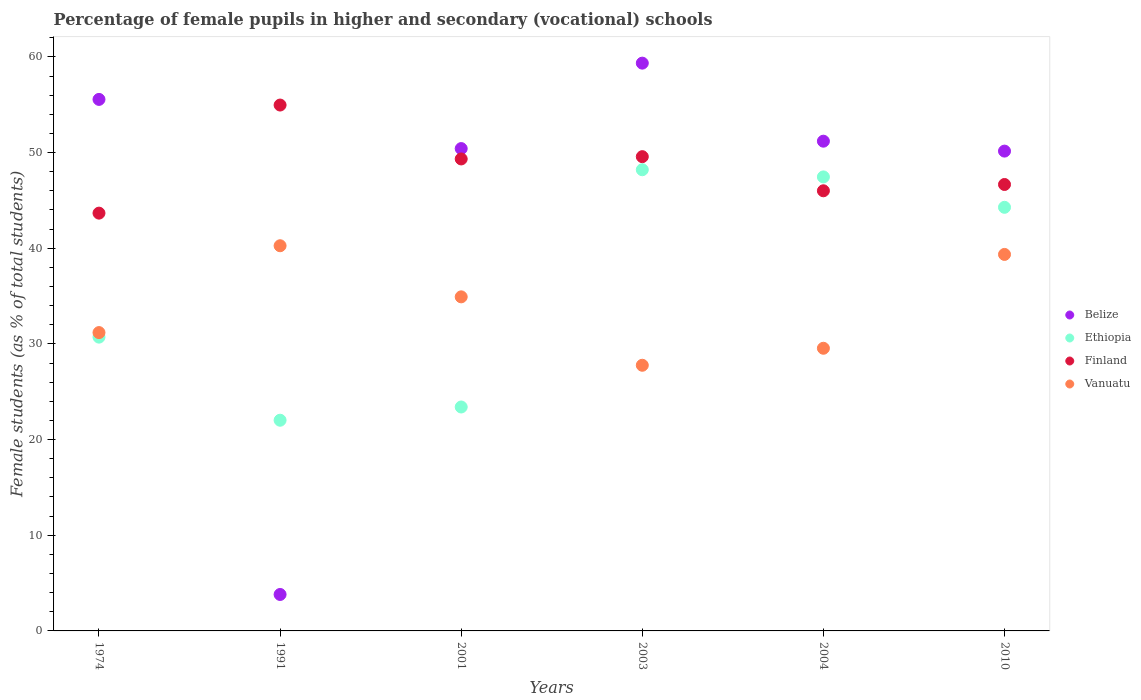How many different coloured dotlines are there?
Ensure brevity in your answer.  4. Is the number of dotlines equal to the number of legend labels?
Give a very brief answer. Yes. What is the percentage of female pupils in higher and secondary schools in Belize in 1991?
Offer a terse response. 3.81. Across all years, what is the maximum percentage of female pupils in higher and secondary schools in Belize?
Make the answer very short. 59.35. Across all years, what is the minimum percentage of female pupils in higher and secondary schools in Vanuatu?
Ensure brevity in your answer.  27.77. In which year was the percentage of female pupils in higher and secondary schools in Belize maximum?
Give a very brief answer. 2003. In which year was the percentage of female pupils in higher and secondary schools in Finland minimum?
Offer a terse response. 1974. What is the total percentage of female pupils in higher and secondary schools in Belize in the graph?
Give a very brief answer. 270.47. What is the difference between the percentage of female pupils in higher and secondary schools in Vanuatu in 1974 and that in 2004?
Your answer should be very brief. 1.64. What is the difference between the percentage of female pupils in higher and secondary schools in Vanuatu in 2004 and the percentage of female pupils in higher and secondary schools in Finland in 1991?
Your response must be concise. -25.42. What is the average percentage of female pupils in higher and secondary schools in Ethiopia per year?
Offer a very short reply. 36.01. In the year 2004, what is the difference between the percentage of female pupils in higher and secondary schools in Vanuatu and percentage of female pupils in higher and secondary schools in Ethiopia?
Your response must be concise. -17.91. What is the ratio of the percentage of female pupils in higher and secondary schools in Finland in 1974 to that in 2010?
Give a very brief answer. 0.94. What is the difference between the highest and the second highest percentage of female pupils in higher and secondary schools in Ethiopia?
Offer a very short reply. 0.75. What is the difference between the highest and the lowest percentage of female pupils in higher and secondary schools in Belize?
Your answer should be very brief. 55.54. Is it the case that in every year, the sum of the percentage of female pupils in higher and secondary schools in Ethiopia and percentage of female pupils in higher and secondary schools in Vanuatu  is greater than the sum of percentage of female pupils in higher and secondary schools in Belize and percentage of female pupils in higher and secondary schools in Finland?
Keep it short and to the point. No. Is it the case that in every year, the sum of the percentage of female pupils in higher and secondary schools in Finland and percentage of female pupils in higher and secondary schools in Vanuatu  is greater than the percentage of female pupils in higher and secondary schools in Belize?
Make the answer very short. Yes. Does the percentage of female pupils in higher and secondary schools in Ethiopia monotonically increase over the years?
Offer a very short reply. No. Is the percentage of female pupils in higher and secondary schools in Belize strictly greater than the percentage of female pupils in higher and secondary schools in Ethiopia over the years?
Your answer should be compact. No. Is the percentage of female pupils in higher and secondary schools in Belize strictly less than the percentage of female pupils in higher and secondary schools in Finland over the years?
Ensure brevity in your answer.  No. How many dotlines are there?
Your answer should be very brief. 4. How many years are there in the graph?
Offer a very short reply. 6. How are the legend labels stacked?
Keep it short and to the point. Vertical. What is the title of the graph?
Offer a terse response. Percentage of female pupils in higher and secondary (vocational) schools. Does "Hong Kong" appear as one of the legend labels in the graph?
Your response must be concise. No. What is the label or title of the X-axis?
Make the answer very short. Years. What is the label or title of the Y-axis?
Give a very brief answer. Female students (as % of total students). What is the Female students (as % of total students) in Belize in 1974?
Keep it short and to the point. 55.56. What is the Female students (as % of total students) in Ethiopia in 1974?
Provide a succinct answer. 30.71. What is the Female students (as % of total students) of Finland in 1974?
Your response must be concise. 43.67. What is the Female students (as % of total students) of Vanuatu in 1974?
Ensure brevity in your answer.  31.18. What is the Female students (as % of total students) in Belize in 1991?
Offer a very short reply. 3.81. What is the Female students (as % of total students) in Ethiopia in 1991?
Your answer should be very brief. 22.02. What is the Female students (as % of total students) in Finland in 1991?
Ensure brevity in your answer.  54.97. What is the Female students (as % of total students) of Vanuatu in 1991?
Your response must be concise. 40.26. What is the Female students (as % of total students) in Belize in 2001?
Make the answer very short. 50.41. What is the Female students (as % of total students) in Ethiopia in 2001?
Keep it short and to the point. 23.41. What is the Female students (as % of total students) of Finland in 2001?
Give a very brief answer. 49.33. What is the Female students (as % of total students) of Vanuatu in 2001?
Provide a short and direct response. 34.92. What is the Female students (as % of total students) of Belize in 2003?
Your answer should be very brief. 59.35. What is the Female students (as % of total students) in Ethiopia in 2003?
Ensure brevity in your answer.  48.2. What is the Female students (as % of total students) of Finland in 2003?
Give a very brief answer. 49.57. What is the Female students (as % of total students) in Vanuatu in 2003?
Ensure brevity in your answer.  27.77. What is the Female students (as % of total students) in Belize in 2004?
Your response must be concise. 51.19. What is the Female students (as % of total students) in Ethiopia in 2004?
Provide a succinct answer. 47.45. What is the Female students (as % of total students) in Finland in 2004?
Keep it short and to the point. 46. What is the Female students (as % of total students) of Vanuatu in 2004?
Offer a very short reply. 29.54. What is the Female students (as % of total students) of Belize in 2010?
Ensure brevity in your answer.  50.15. What is the Female students (as % of total students) of Ethiopia in 2010?
Ensure brevity in your answer.  44.28. What is the Female students (as % of total students) in Finland in 2010?
Offer a terse response. 46.66. What is the Female students (as % of total students) of Vanuatu in 2010?
Make the answer very short. 39.35. Across all years, what is the maximum Female students (as % of total students) in Belize?
Your response must be concise. 59.35. Across all years, what is the maximum Female students (as % of total students) of Ethiopia?
Keep it short and to the point. 48.2. Across all years, what is the maximum Female students (as % of total students) of Finland?
Offer a very short reply. 54.97. Across all years, what is the maximum Female students (as % of total students) in Vanuatu?
Your answer should be very brief. 40.26. Across all years, what is the minimum Female students (as % of total students) in Belize?
Give a very brief answer. 3.81. Across all years, what is the minimum Female students (as % of total students) of Ethiopia?
Offer a terse response. 22.02. Across all years, what is the minimum Female students (as % of total students) of Finland?
Your answer should be compact. 43.67. Across all years, what is the minimum Female students (as % of total students) of Vanuatu?
Your answer should be very brief. 27.77. What is the total Female students (as % of total students) of Belize in the graph?
Ensure brevity in your answer.  270.47. What is the total Female students (as % of total students) of Ethiopia in the graph?
Offer a very short reply. 216.07. What is the total Female students (as % of total students) in Finland in the graph?
Keep it short and to the point. 290.2. What is the total Female students (as % of total students) of Vanuatu in the graph?
Your answer should be very brief. 203.02. What is the difference between the Female students (as % of total students) in Belize in 1974 and that in 1991?
Your answer should be very brief. 51.75. What is the difference between the Female students (as % of total students) of Ethiopia in 1974 and that in 1991?
Offer a terse response. 8.69. What is the difference between the Female students (as % of total students) of Finland in 1974 and that in 1991?
Your response must be concise. -11.3. What is the difference between the Female students (as % of total students) of Vanuatu in 1974 and that in 1991?
Your response must be concise. -9.08. What is the difference between the Female students (as % of total students) of Belize in 1974 and that in 2001?
Keep it short and to the point. 5.14. What is the difference between the Female students (as % of total students) of Ethiopia in 1974 and that in 2001?
Offer a very short reply. 7.3. What is the difference between the Female students (as % of total students) of Finland in 1974 and that in 2001?
Make the answer very short. -5.66. What is the difference between the Female students (as % of total students) in Vanuatu in 1974 and that in 2001?
Offer a terse response. -3.73. What is the difference between the Female students (as % of total students) in Belize in 1974 and that in 2003?
Your answer should be very brief. -3.79. What is the difference between the Female students (as % of total students) of Ethiopia in 1974 and that in 2003?
Keep it short and to the point. -17.5. What is the difference between the Female students (as % of total students) in Finland in 1974 and that in 2003?
Make the answer very short. -5.9. What is the difference between the Female students (as % of total students) of Vanuatu in 1974 and that in 2003?
Your answer should be very brief. 3.42. What is the difference between the Female students (as % of total students) in Belize in 1974 and that in 2004?
Provide a short and direct response. 4.37. What is the difference between the Female students (as % of total students) in Ethiopia in 1974 and that in 2004?
Give a very brief answer. -16.75. What is the difference between the Female students (as % of total students) in Finland in 1974 and that in 2004?
Give a very brief answer. -2.34. What is the difference between the Female students (as % of total students) of Vanuatu in 1974 and that in 2004?
Make the answer very short. 1.64. What is the difference between the Female students (as % of total students) in Belize in 1974 and that in 2010?
Keep it short and to the point. 5.4. What is the difference between the Female students (as % of total students) of Ethiopia in 1974 and that in 2010?
Ensure brevity in your answer.  -13.57. What is the difference between the Female students (as % of total students) in Finland in 1974 and that in 2010?
Offer a very short reply. -2.99. What is the difference between the Female students (as % of total students) in Vanuatu in 1974 and that in 2010?
Provide a short and direct response. -8.17. What is the difference between the Female students (as % of total students) in Belize in 1991 and that in 2001?
Make the answer very short. -46.61. What is the difference between the Female students (as % of total students) of Ethiopia in 1991 and that in 2001?
Offer a very short reply. -1.38. What is the difference between the Female students (as % of total students) of Finland in 1991 and that in 2001?
Give a very brief answer. 5.63. What is the difference between the Female students (as % of total students) in Vanuatu in 1991 and that in 2001?
Give a very brief answer. 5.34. What is the difference between the Female students (as % of total students) in Belize in 1991 and that in 2003?
Your answer should be compact. -55.54. What is the difference between the Female students (as % of total students) in Ethiopia in 1991 and that in 2003?
Make the answer very short. -26.18. What is the difference between the Female students (as % of total students) of Finland in 1991 and that in 2003?
Your response must be concise. 5.39. What is the difference between the Female students (as % of total students) of Vanuatu in 1991 and that in 2003?
Give a very brief answer. 12.49. What is the difference between the Female students (as % of total students) in Belize in 1991 and that in 2004?
Ensure brevity in your answer.  -47.38. What is the difference between the Female students (as % of total students) in Ethiopia in 1991 and that in 2004?
Your response must be concise. -25.43. What is the difference between the Female students (as % of total students) of Finland in 1991 and that in 2004?
Your answer should be compact. 8.96. What is the difference between the Female students (as % of total students) of Vanuatu in 1991 and that in 2004?
Give a very brief answer. 10.72. What is the difference between the Female students (as % of total students) of Belize in 1991 and that in 2010?
Make the answer very short. -46.34. What is the difference between the Female students (as % of total students) in Ethiopia in 1991 and that in 2010?
Offer a terse response. -22.25. What is the difference between the Female students (as % of total students) in Finland in 1991 and that in 2010?
Ensure brevity in your answer.  8.3. What is the difference between the Female students (as % of total students) of Vanuatu in 1991 and that in 2010?
Your response must be concise. 0.91. What is the difference between the Female students (as % of total students) in Belize in 2001 and that in 2003?
Provide a short and direct response. -8.93. What is the difference between the Female students (as % of total students) in Ethiopia in 2001 and that in 2003?
Give a very brief answer. -24.8. What is the difference between the Female students (as % of total students) of Finland in 2001 and that in 2003?
Offer a very short reply. -0.24. What is the difference between the Female students (as % of total students) in Vanuatu in 2001 and that in 2003?
Give a very brief answer. 7.15. What is the difference between the Female students (as % of total students) in Belize in 2001 and that in 2004?
Your response must be concise. -0.77. What is the difference between the Female students (as % of total students) in Ethiopia in 2001 and that in 2004?
Your response must be concise. -24.05. What is the difference between the Female students (as % of total students) in Finland in 2001 and that in 2004?
Make the answer very short. 3.33. What is the difference between the Female students (as % of total students) in Vanuatu in 2001 and that in 2004?
Provide a succinct answer. 5.37. What is the difference between the Female students (as % of total students) in Belize in 2001 and that in 2010?
Give a very brief answer. 0.26. What is the difference between the Female students (as % of total students) in Ethiopia in 2001 and that in 2010?
Provide a short and direct response. -20.87. What is the difference between the Female students (as % of total students) of Finland in 2001 and that in 2010?
Provide a short and direct response. 2.67. What is the difference between the Female students (as % of total students) in Vanuatu in 2001 and that in 2010?
Give a very brief answer. -4.43. What is the difference between the Female students (as % of total students) in Belize in 2003 and that in 2004?
Your response must be concise. 8.16. What is the difference between the Female students (as % of total students) of Ethiopia in 2003 and that in 2004?
Provide a short and direct response. 0.75. What is the difference between the Female students (as % of total students) of Finland in 2003 and that in 2004?
Provide a succinct answer. 3.57. What is the difference between the Female students (as % of total students) in Vanuatu in 2003 and that in 2004?
Offer a terse response. -1.78. What is the difference between the Female students (as % of total students) in Belize in 2003 and that in 2010?
Provide a succinct answer. 9.19. What is the difference between the Female students (as % of total students) in Ethiopia in 2003 and that in 2010?
Make the answer very short. 3.93. What is the difference between the Female students (as % of total students) of Finland in 2003 and that in 2010?
Provide a short and direct response. 2.91. What is the difference between the Female students (as % of total students) in Vanuatu in 2003 and that in 2010?
Provide a succinct answer. -11.59. What is the difference between the Female students (as % of total students) of Belize in 2004 and that in 2010?
Give a very brief answer. 1.04. What is the difference between the Female students (as % of total students) in Ethiopia in 2004 and that in 2010?
Offer a very short reply. 3.18. What is the difference between the Female students (as % of total students) of Finland in 2004 and that in 2010?
Offer a very short reply. -0.66. What is the difference between the Female students (as % of total students) in Vanuatu in 2004 and that in 2010?
Your response must be concise. -9.81. What is the difference between the Female students (as % of total students) of Belize in 1974 and the Female students (as % of total students) of Ethiopia in 1991?
Your answer should be very brief. 33.53. What is the difference between the Female students (as % of total students) of Belize in 1974 and the Female students (as % of total students) of Finland in 1991?
Provide a short and direct response. 0.59. What is the difference between the Female students (as % of total students) in Belize in 1974 and the Female students (as % of total students) in Vanuatu in 1991?
Provide a succinct answer. 15.3. What is the difference between the Female students (as % of total students) in Ethiopia in 1974 and the Female students (as % of total students) in Finland in 1991?
Provide a succinct answer. -24.26. What is the difference between the Female students (as % of total students) in Ethiopia in 1974 and the Female students (as % of total students) in Vanuatu in 1991?
Ensure brevity in your answer.  -9.55. What is the difference between the Female students (as % of total students) of Finland in 1974 and the Female students (as % of total students) of Vanuatu in 1991?
Offer a terse response. 3.41. What is the difference between the Female students (as % of total students) in Belize in 1974 and the Female students (as % of total students) in Ethiopia in 2001?
Offer a very short reply. 32.15. What is the difference between the Female students (as % of total students) of Belize in 1974 and the Female students (as % of total students) of Finland in 2001?
Make the answer very short. 6.22. What is the difference between the Female students (as % of total students) of Belize in 1974 and the Female students (as % of total students) of Vanuatu in 2001?
Your answer should be very brief. 20.64. What is the difference between the Female students (as % of total students) of Ethiopia in 1974 and the Female students (as % of total students) of Finland in 2001?
Provide a short and direct response. -18.62. What is the difference between the Female students (as % of total students) in Ethiopia in 1974 and the Female students (as % of total students) in Vanuatu in 2001?
Your response must be concise. -4.21. What is the difference between the Female students (as % of total students) in Finland in 1974 and the Female students (as % of total students) in Vanuatu in 2001?
Your answer should be very brief. 8.75. What is the difference between the Female students (as % of total students) in Belize in 1974 and the Female students (as % of total students) in Ethiopia in 2003?
Keep it short and to the point. 7.35. What is the difference between the Female students (as % of total students) of Belize in 1974 and the Female students (as % of total students) of Finland in 2003?
Your answer should be compact. 5.98. What is the difference between the Female students (as % of total students) in Belize in 1974 and the Female students (as % of total students) in Vanuatu in 2003?
Give a very brief answer. 27.79. What is the difference between the Female students (as % of total students) of Ethiopia in 1974 and the Female students (as % of total students) of Finland in 2003?
Your answer should be very brief. -18.86. What is the difference between the Female students (as % of total students) in Ethiopia in 1974 and the Female students (as % of total students) in Vanuatu in 2003?
Your answer should be very brief. 2.94. What is the difference between the Female students (as % of total students) in Finland in 1974 and the Female students (as % of total students) in Vanuatu in 2003?
Make the answer very short. 15.9. What is the difference between the Female students (as % of total students) of Belize in 1974 and the Female students (as % of total students) of Ethiopia in 2004?
Provide a short and direct response. 8.1. What is the difference between the Female students (as % of total students) of Belize in 1974 and the Female students (as % of total students) of Finland in 2004?
Keep it short and to the point. 9.55. What is the difference between the Female students (as % of total students) in Belize in 1974 and the Female students (as % of total students) in Vanuatu in 2004?
Keep it short and to the point. 26.01. What is the difference between the Female students (as % of total students) in Ethiopia in 1974 and the Female students (as % of total students) in Finland in 2004?
Provide a succinct answer. -15.3. What is the difference between the Female students (as % of total students) in Ethiopia in 1974 and the Female students (as % of total students) in Vanuatu in 2004?
Your answer should be very brief. 1.16. What is the difference between the Female students (as % of total students) of Finland in 1974 and the Female students (as % of total students) of Vanuatu in 2004?
Your answer should be compact. 14.12. What is the difference between the Female students (as % of total students) of Belize in 1974 and the Female students (as % of total students) of Ethiopia in 2010?
Offer a terse response. 11.28. What is the difference between the Female students (as % of total students) of Belize in 1974 and the Female students (as % of total students) of Finland in 2010?
Ensure brevity in your answer.  8.89. What is the difference between the Female students (as % of total students) in Belize in 1974 and the Female students (as % of total students) in Vanuatu in 2010?
Offer a very short reply. 16.2. What is the difference between the Female students (as % of total students) of Ethiopia in 1974 and the Female students (as % of total students) of Finland in 2010?
Your answer should be very brief. -15.95. What is the difference between the Female students (as % of total students) in Ethiopia in 1974 and the Female students (as % of total students) in Vanuatu in 2010?
Provide a short and direct response. -8.64. What is the difference between the Female students (as % of total students) in Finland in 1974 and the Female students (as % of total students) in Vanuatu in 2010?
Give a very brief answer. 4.32. What is the difference between the Female students (as % of total students) of Belize in 1991 and the Female students (as % of total students) of Ethiopia in 2001?
Make the answer very short. -19.6. What is the difference between the Female students (as % of total students) in Belize in 1991 and the Female students (as % of total students) in Finland in 2001?
Give a very brief answer. -45.52. What is the difference between the Female students (as % of total students) of Belize in 1991 and the Female students (as % of total students) of Vanuatu in 2001?
Offer a terse response. -31.11. What is the difference between the Female students (as % of total students) in Ethiopia in 1991 and the Female students (as % of total students) in Finland in 2001?
Make the answer very short. -27.31. What is the difference between the Female students (as % of total students) in Ethiopia in 1991 and the Female students (as % of total students) in Vanuatu in 2001?
Your answer should be very brief. -12.9. What is the difference between the Female students (as % of total students) of Finland in 1991 and the Female students (as % of total students) of Vanuatu in 2001?
Provide a short and direct response. 20.05. What is the difference between the Female students (as % of total students) of Belize in 1991 and the Female students (as % of total students) of Ethiopia in 2003?
Ensure brevity in your answer.  -44.39. What is the difference between the Female students (as % of total students) of Belize in 1991 and the Female students (as % of total students) of Finland in 2003?
Make the answer very short. -45.76. What is the difference between the Female students (as % of total students) in Belize in 1991 and the Female students (as % of total students) in Vanuatu in 2003?
Your response must be concise. -23.96. What is the difference between the Female students (as % of total students) of Ethiopia in 1991 and the Female students (as % of total students) of Finland in 2003?
Keep it short and to the point. -27.55. What is the difference between the Female students (as % of total students) of Ethiopia in 1991 and the Female students (as % of total students) of Vanuatu in 2003?
Keep it short and to the point. -5.74. What is the difference between the Female students (as % of total students) in Finland in 1991 and the Female students (as % of total students) in Vanuatu in 2003?
Provide a succinct answer. 27.2. What is the difference between the Female students (as % of total students) of Belize in 1991 and the Female students (as % of total students) of Ethiopia in 2004?
Provide a short and direct response. -43.64. What is the difference between the Female students (as % of total students) of Belize in 1991 and the Female students (as % of total students) of Finland in 2004?
Provide a short and direct response. -42.19. What is the difference between the Female students (as % of total students) of Belize in 1991 and the Female students (as % of total students) of Vanuatu in 2004?
Provide a short and direct response. -25.73. What is the difference between the Female students (as % of total students) in Ethiopia in 1991 and the Female students (as % of total students) in Finland in 2004?
Your response must be concise. -23.98. What is the difference between the Female students (as % of total students) of Ethiopia in 1991 and the Female students (as % of total students) of Vanuatu in 2004?
Offer a very short reply. -7.52. What is the difference between the Female students (as % of total students) in Finland in 1991 and the Female students (as % of total students) in Vanuatu in 2004?
Offer a very short reply. 25.42. What is the difference between the Female students (as % of total students) of Belize in 1991 and the Female students (as % of total students) of Ethiopia in 2010?
Give a very brief answer. -40.47. What is the difference between the Female students (as % of total students) in Belize in 1991 and the Female students (as % of total students) in Finland in 2010?
Give a very brief answer. -42.85. What is the difference between the Female students (as % of total students) of Belize in 1991 and the Female students (as % of total students) of Vanuatu in 2010?
Make the answer very short. -35.54. What is the difference between the Female students (as % of total students) of Ethiopia in 1991 and the Female students (as % of total students) of Finland in 2010?
Your response must be concise. -24.64. What is the difference between the Female students (as % of total students) of Ethiopia in 1991 and the Female students (as % of total students) of Vanuatu in 2010?
Provide a succinct answer. -17.33. What is the difference between the Female students (as % of total students) in Finland in 1991 and the Female students (as % of total students) in Vanuatu in 2010?
Your answer should be compact. 15.61. What is the difference between the Female students (as % of total students) in Belize in 2001 and the Female students (as % of total students) in Ethiopia in 2003?
Ensure brevity in your answer.  2.21. What is the difference between the Female students (as % of total students) of Belize in 2001 and the Female students (as % of total students) of Finland in 2003?
Your response must be concise. 0.84. What is the difference between the Female students (as % of total students) of Belize in 2001 and the Female students (as % of total students) of Vanuatu in 2003?
Your response must be concise. 22.65. What is the difference between the Female students (as % of total students) in Ethiopia in 2001 and the Female students (as % of total students) in Finland in 2003?
Your answer should be very brief. -26.17. What is the difference between the Female students (as % of total students) of Ethiopia in 2001 and the Female students (as % of total students) of Vanuatu in 2003?
Make the answer very short. -4.36. What is the difference between the Female students (as % of total students) of Finland in 2001 and the Female students (as % of total students) of Vanuatu in 2003?
Your answer should be compact. 21.57. What is the difference between the Female students (as % of total students) of Belize in 2001 and the Female students (as % of total students) of Ethiopia in 2004?
Make the answer very short. 2.96. What is the difference between the Female students (as % of total students) in Belize in 2001 and the Female students (as % of total students) in Finland in 2004?
Offer a terse response. 4.41. What is the difference between the Female students (as % of total students) in Belize in 2001 and the Female students (as % of total students) in Vanuatu in 2004?
Offer a very short reply. 20.87. What is the difference between the Female students (as % of total students) in Ethiopia in 2001 and the Female students (as % of total students) in Finland in 2004?
Your answer should be very brief. -22.6. What is the difference between the Female students (as % of total students) in Ethiopia in 2001 and the Female students (as % of total students) in Vanuatu in 2004?
Ensure brevity in your answer.  -6.14. What is the difference between the Female students (as % of total students) of Finland in 2001 and the Female students (as % of total students) of Vanuatu in 2004?
Offer a terse response. 19.79. What is the difference between the Female students (as % of total students) of Belize in 2001 and the Female students (as % of total students) of Ethiopia in 2010?
Give a very brief answer. 6.14. What is the difference between the Female students (as % of total students) in Belize in 2001 and the Female students (as % of total students) in Finland in 2010?
Ensure brevity in your answer.  3.75. What is the difference between the Female students (as % of total students) in Belize in 2001 and the Female students (as % of total students) in Vanuatu in 2010?
Provide a succinct answer. 11.06. What is the difference between the Female students (as % of total students) of Ethiopia in 2001 and the Female students (as % of total students) of Finland in 2010?
Provide a short and direct response. -23.26. What is the difference between the Female students (as % of total students) of Ethiopia in 2001 and the Female students (as % of total students) of Vanuatu in 2010?
Your answer should be very brief. -15.95. What is the difference between the Female students (as % of total students) in Finland in 2001 and the Female students (as % of total students) in Vanuatu in 2010?
Make the answer very short. 9.98. What is the difference between the Female students (as % of total students) in Belize in 2003 and the Female students (as % of total students) in Ethiopia in 2004?
Your response must be concise. 11.89. What is the difference between the Female students (as % of total students) in Belize in 2003 and the Female students (as % of total students) in Finland in 2004?
Your answer should be compact. 13.34. What is the difference between the Female students (as % of total students) of Belize in 2003 and the Female students (as % of total students) of Vanuatu in 2004?
Provide a short and direct response. 29.8. What is the difference between the Female students (as % of total students) of Ethiopia in 2003 and the Female students (as % of total students) of Vanuatu in 2004?
Ensure brevity in your answer.  18.66. What is the difference between the Female students (as % of total students) in Finland in 2003 and the Female students (as % of total students) in Vanuatu in 2004?
Make the answer very short. 20.03. What is the difference between the Female students (as % of total students) of Belize in 2003 and the Female students (as % of total students) of Ethiopia in 2010?
Make the answer very short. 15.07. What is the difference between the Female students (as % of total students) in Belize in 2003 and the Female students (as % of total students) in Finland in 2010?
Your response must be concise. 12.68. What is the difference between the Female students (as % of total students) of Belize in 2003 and the Female students (as % of total students) of Vanuatu in 2010?
Your answer should be compact. 19.99. What is the difference between the Female students (as % of total students) in Ethiopia in 2003 and the Female students (as % of total students) in Finland in 2010?
Keep it short and to the point. 1.54. What is the difference between the Female students (as % of total students) of Ethiopia in 2003 and the Female students (as % of total students) of Vanuatu in 2010?
Provide a succinct answer. 8.85. What is the difference between the Female students (as % of total students) of Finland in 2003 and the Female students (as % of total students) of Vanuatu in 2010?
Keep it short and to the point. 10.22. What is the difference between the Female students (as % of total students) in Belize in 2004 and the Female students (as % of total students) in Ethiopia in 2010?
Keep it short and to the point. 6.91. What is the difference between the Female students (as % of total students) in Belize in 2004 and the Female students (as % of total students) in Finland in 2010?
Provide a short and direct response. 4.53. What is the difference between the Female students (as % of total students) of Belize in 2004 and the Female students (as % of total students) of Vanuatu in 2010?
Offer a very short reply. 11.84. What is the difference between the Female students (as % of total students) of Ethiopia in 2004 and the Female students (as % of total students) of Finland in 2010?
Offer a terse response. 0.79. What is the difference between the Female students (as % of total students) in Ethiopia in 2004 and the Female students (as % of total students) in Vanuatu in 2010?
Give a very brief answer. 8.1. What is the difference between the Female students (as % of total students) of Finland in 2004 and the Female students (as % of total students) of Vanuatu in 2010?
Give a very brief answer. 6.65. What is the average Female students (as % of total students) of Belize per year?
Offer a terse response. 45.08. What is the average Female students (as % of total students) in Ethiopia per year?
Offer a very short reply. 36.01. What is the average Female students (as % of total students) in Finland per year?
Your response must be concise. 48.37. What is the average Female students (as % of total students) in Vanuatu per year?
Your response must be concise. 33.84. In the year 1974, what is the difference between the Female students (as % of total students) in Belize and Female students (as % of total students) in Ethiopia?
Provide a succinct answer. 24.85. In the year 1974, what is the difference between the Female students (as % of total students) in Belize and Female students (as % of total students) in Finland?
Keep it short and to the point. 11.89. In the year 1974, what is the difference between the Female students (as % of total students) in Belize and Female students (as % of total students) in Vanuatu?
Offer a terse response. 24.37. In the year 1974, what is the difference between the Female students (as % of total students) of Ethiopia and Female students (as % of total students) of Finland?
Provide a succinct answer. -12.96. In the year 1974, what is the difference between the Female students (as % of total students) of Ethiopia and Female students (as % of total students) of Vanuatu?
Offer a terse response. -0.47. In the year 1974, what is the difference between the Female students (as % of total students) in Finland and Female students (as % of total students) in Vanuatu?
Provide a short and direct response. 12.48. In the year 1991, what is the difference between the Female students (as % of total students) of Belize and Female students (as % of total students) of Ethiopia?
Provide a succinct answer. -18.21. In the year 1991, what is the difference between the Female students (as % of total students) of Belize and Female students (as % of total students) of Finland?
Make the answer very short. -51.16. In the year 1991, what is the difference between the Female students (as % of total students) in Belize and Female students (as % of total students) in Vanuatu?
Offer a terse response. -36.45. In the year 1991, what is the difference between the Female students (as % of total students) of Ethiopia and Female students (as % of total students) of Finland?
Your response must be concise. -32.94. In the year 1991, what is the difference between the Female students (as % of total students) in Ethiopia and Female students (as % of total students) in Vanuatu?
Your response must be concise. -18.24. In the year 1991, what is the difference between the Female students (as % of total students) of Finland and Female students (as % of total students) of Vanuatu?
Provide a succinct answer. 14.71. In the year 2001, what is the difference between the Female students (as % of total students) of Belize and Female students (as % of total students) of Ethiopia?
Your response must be concise. 27.01. In the year 2001, what is the difference between the Female students (as % of total students) in Belize and Female students (as % of total students) in Finland?
Offer a very short reply. 1.08. In the year 2001, what is the difference between the Female students (as % of total students) in Belize and Female students (as % of total students) in Vanuatu?
Your answer should be compact. 15.5. In the year 2001, what is the difference between the Female students (as % of total students) in Ethiopia and Female students (as % of total students) in Finland?
Offer a terse response. -25.93. In the year 2001, what is the difference between the Female students (as % of total students) of Ethiopia and Female students (as % of total students) of Vanuatu?
Your response must be concise. -11.51. In the year 2001, what is the difference between the Female students (as % of total students) of Finland and Female students (as % of total students) of Vanuatu?
Ensure brevity in your answer.  14.41. In the year 2003, what is the difference between the Female students (as % of total students) in Belize and Female students (as % of total students) in Ethiopia?
Keep it short and to the point. 11.14. In the year 2003, what is the difference between the Female students (as % of total students) of Belize and Female students (as % of total students) of Finland?
Offer a very short reply. 9.78. In the year 2003, what is the difference between the Female students (as % of total students) of Belize and Female students (as % of total students) of Vanuatu?
Ensure brevity in your answer.  31.58. In the year 2003, what is the difference between the Female students (as % of total students) of Ethiopia and Female students (as % of total students) of Finland?
Offer a very short reply. -1.37. In the year 2003, what is the difference between the Female students (as % of total students) of Ethiopia and Female students (as % of total students) of Vanuatu?
Your answer should be compact. 20.44. In the year 2003, what is the difference between the Female students (as % of total students) in Finland and Female students (as % of total students) in Vanuatu?
Your answer should be very brief. 21.8. In the year 2004, what is the difference between the Female students (as % of total students) of Belize and Female students (as % of total students) of Ethiopia?
Keep it short and to the point. 3.73. In the year 2004, what is the difference between the Female students (as % of total students) of Belize and Female students (as % of total students) of Finland?
Provide a succinct answer. 5.18. In the year 2004, what is the difference between the Female students (as % of total students) of Belize and Female students (as % of total students) of Vanuatu?
Provide a short and direct response. 21.64. In the year 2004, what is the difference between the Female students (as % of total students) of Ethiopia and Female students (as % of total students) of Finland?
Ensure brevity in your answer.  1.45. In the year 2004, what is the difference between the Female students (as % of total students) in Ethiopia and Female students (as % of total students) in Vanuatu?
Ensure brevity in your answer.  17.91. In the year 2004, what is the difference between the Female students (as % of total students) in Finland and Female students (as % of total students) in Vanuatu?
Offer a very short reply. 16.46. In the year 2010, what is the difference between the Female students (as % of total students) of Belize and Female students (as % of total students) of Ethiopia?
Your answer should be very brief. 5.87. In the year 2010, what is the difference between the Female students (as % of total students) in Belize and Female students (as % of total students) in Finland?
Provide a succinct answer. 3.49. In the year 2010, what is the difference between the Female students (as % of total students) in Belize and Female students (as % of total students) in Vanuatu?
Your answer should be very brief. 10.8. In the year 2010, what is the difference between the Female students (as % of total students) of Ethiopia and Female students (as % of total students) of Finland?
Keep it short and to the point. -2.39. In the year 2010, what is the difference between the Female students (as % of total students) in Ethiopia and Female students (as % of total students) in Vanuatu?
Make the answer very short. 4.92. In the year 2010, what is the difference between the Female students (as % of total students) of Finland and Female students (as % of total students) of Vanuatu?
Your response must be concise. 7.31. What is the ratio of the Female students (as % of total students) in Belize in 1974 to that in 1991?
Offer a terse response. 14.58. What is the ratio of the Female students (as % of total students) of Ethiopia in 1974 to that in 1991?
Keep it short and to the point. 1.39. What is the ratio of the Female students (as % of total students) in Finland in 1974 to that in 1991?
Offer a terse response. 0.79. What is the ratio of the Female students (as % of total students) of Vanuatu in 1974 to that in 1991?
Make the answer very short. 0.77. What is the ratio of the Female students (as % of total students) in Belize in 1974 to that in 2001?
Give a very brief answer. 1.1. What is the ratio of the Female students (as % of total students) of Ethiopia in 1974 to that in 2001?
Ensure brevity in your answer.  1.31. What is the ratio of the Female students (as % of total students) of Finland in 1974 to that in 2001?
Give a very brief answer. 0.89. What is the ratio of the Female students (as % of total students) of Vanuatu in 1974 to that in 2001?
Offer a terse response. 0.89. What is the ratio of the Female students (as % of total students) in Belize in 1974 to that in 2003?
Give a very brief answer. 0.94. What is the ratio of the Female students (as % of total students) in Ethiopia in 1974 to that in 2003?
Your response must be concise. 0.64. What is the ratio of the Female students (as % of total students) in Finland in 1974 to that in 2003?
Your answer should be very brief. 0.88. What is the ratio of the Female students (as % of total students) of Vanuatu in 1974 to that in 2003?
Offer a very short reply. 1.12. What is the ratio of the Female students (as % of total students) in Belize in 1974 to that in 2004?
Your response must be concise. 1.09. What is the ratio of the Female students (as % of total students) in Ethiopia in 1974 to that in 2004?
Make the answer very short. 0.65. What is the ratio of the Female students (as % of total students) in Finland in 1974 to that in 2004?
Give a very brief answer. 0.95. What is the ratio of the Female students (as % of total students) of Vanuatu in 1974 to that in 2004?
Ensure brevity in your answer.  1.06. What is the ratio of the Female students (as % of total students) of Belize in 1974 to that in 2010?
Provide a succinct answer. 1.11. What is the ratio of the Female students (as % of total students) of Ethiopia in 1974 to that in 2010?
Offer a terse response. 0.69. What is the ratio of the Female students (as % of total students) of Finland in 1974 to that in 2010?
Keep it short and to the point. 0.94. What is the ratio of the Female students (as % of total students) in Vanuatu in 1974 to that in 2010?
Your response must be concise. 0.79. What is the ratio of the Female students (as % of total students) in Belize in 1991 to that in 2001?
Your answer should be very brief. 0.08. What is the ratio of the Female students (as % of total students) in Ethiopia in 1991 to that in 2001?
Your answer should be compact. 0.94. What is the ratio of the Female students (as % of total students) in Finland in 1991 to that in 2001?
Provide a succinct answer. 1.11. What is the ratio of the Female students (as % of total students) in Vanuatu in 1991 to that in 2001?
Ensure brevity in your answer.  1.15. What is the ratio of the Female students (as % of total students) in Belize in 1991 to that in 2003?
Provide a short and direct response. 0.06. What is the ratio of the Female students (as % of total students) in Ethiopia in 1991 to that in 2003?
Your answer should be very brief. 0.46. What is the ratio of the Female students (as % of total students) in Finland in 1991 to that in 2003?
Ensure brevity in your answer.  1.11. What is the ratio of the Female students (as % of total students) of Vanuatu in 1991 to that in 2003?
Offer a very short reply. 1.45. What is the ratio of the Female students (as % of total students) of Belize in 1991 to that in 2004?
Offer a terse response. 0.07. What is the ratio of the Female students (as % of total students) in Ethiopia in 1991 to that in 2004?
Give a very brief answer. 0.46. What is the ratio of the Female students (as % of total students) in Finland in 1991 to that in 2004?
Offer a terse response. 1.19. What is the ratio of the Female students (as % of total students) in Vanuatu in 1991 to that in 2004?
Provide a succinct answer. 1.36. What is the ratio of the Female students (as % of total students) in Belize in 1991 to that in 2010?
Offer a very short reply. 0.08. What is the ratio of the Female students (as % of total students) of Ethiopia in 1991 to that in 2010?
Keep it short and to the point. 0.5. What is the ratio of the Female students (as % of total students) of Finland in 1991 to that in 2010?
Provide a succinct answer. 1.18. What is the ratio of the Female students (as % of total students) in Vanuatu in 1991 to that in 2010?
Provide a short and direct response. 1.02. What is the ratio of the Female students (as % of total students) in Belize in 2001 to that in 2003?
Provide a succinct answer. 0.85. What is the ratio of the Female students (as % of total students) of Ethiopia in 2001 to that in 2003?
Your answer should be compact. 0.49. What is the ratio of the Female students (as % of total students) of Finland in 2001 to that in 2003?
Give a very brief answer. 1. What is the ratio of the Female students (as % of total students) in Vanuatu in 2001 to that in 2003?
Ensure brevity in your answer.  1.26. What is the ratio of the Female students (as % of total students) of Belize in 2001 to that in 2004?
Your answer should be very brief. 0.98. What is the ratio of the Female students (as % of total students) of Ethiopia in 2001 to that in 2004?
Offer a very short reply. 0.49. What is the ratio of the Female students (as % of total students) of Finland in 2001 to that in 2004?
Ensure brevity in your answer.  1.07. What is the ratio of the Female students (as % of total students) in Vanuatu in 2001 to that in 2004?
Make the answer very short. 1.18. What is the ratio of the Female students (as % of total students) in Ethiopia in 2001 to that in 2010?
Offer a terse response. 0.53. What is the ratio of the Female students (as % of total students) of Finland in 2001 to that in 2010?
Provide a short and direct response. 1.06. What is the ratio of the Female students (as % of total students) in Vanuatu in 2001 to that in 2010?
Offer a very short reply. 0.89. What is the ratio of the Female students (as % of total students) in Belize in 2003 to that in 2004?
Offer a terse response. 1.16. What is the ratio of the Female students (as % of total students) in Ethiopia in 2003 to that in 2004?
Offer a very short reply. 1.02. What is the ratio of the Female students (as % of total students) of Finland in 2003 to that in 2004?
Provide a short and direct response. 1.08. What is the ratio of the Female students (as % of total students) of Vanuatu in 2003 to that in 2004?
Your answer should be very brief. 0.94. What is the ratio of the Female students (as % of total students) in Belize in 2003 to that in 2010?
Your answer should be very brief. 1.18. What is the ratio of the Female students (as % of total students) in Ethiopia in 2003 to that in 2010?
Offer a terse response. 1.09. What is the ratio of the Female students (as % of total students) of Finland in 2003 to that in 2010?
Ensure brevity in your answer.  1.06. What is the ratio of the Female students (as % of total students) of Vanuatu in 2003 to that in 2010?
Provide a succinct answer. 0.71. What is the ratio of the Female students (as % of total students) of Belize in 2004 to that in 2010?
Offer a very short reply. 1.02. What is the ratio of the Female students (as % of total students) in Ethiopia in 2004 to that in 2010?
Your answer should be compact. 1.07. What is the ratio of the Female students (as % of total students) in Finland in 2004 to that in 2010?
Your answer should be very brief. 0.99. What is the ratio of the Female students (as % of total students) of Vanuatu in 2004 to that in 2010?
Your response must be concise. 0.75. What is the difference between the highest and the second highest Female students (as % of total students) of Belize?
Give a very brief answer. 3.79. What is the difference between the highest and the second highest Female students (as % of total students) of Finland?
Offer a terse response. 5.39. What is the difference between the highest and the second highest Female students (as % of total students) in Vanuatu?
Offer a very short reply. 0.91. What is the difference between the highest and the lowest Female students (as % of total students) in Belize?
Keep it short and to the point. 55.54. What is the difference between the highest and the lowest Female students (as % of total students) in Ethiopia?
Give a very brief answer. 26.18. What is the difference between the highest and the lowest Female students (as % of total students) in Finland?
Ensure brevity in your answer.  11.3. What is the difference between the highest and the lowest Female students (as % of total students) of Vanuatu?
Ensure brevity in your answer.  12.49. 